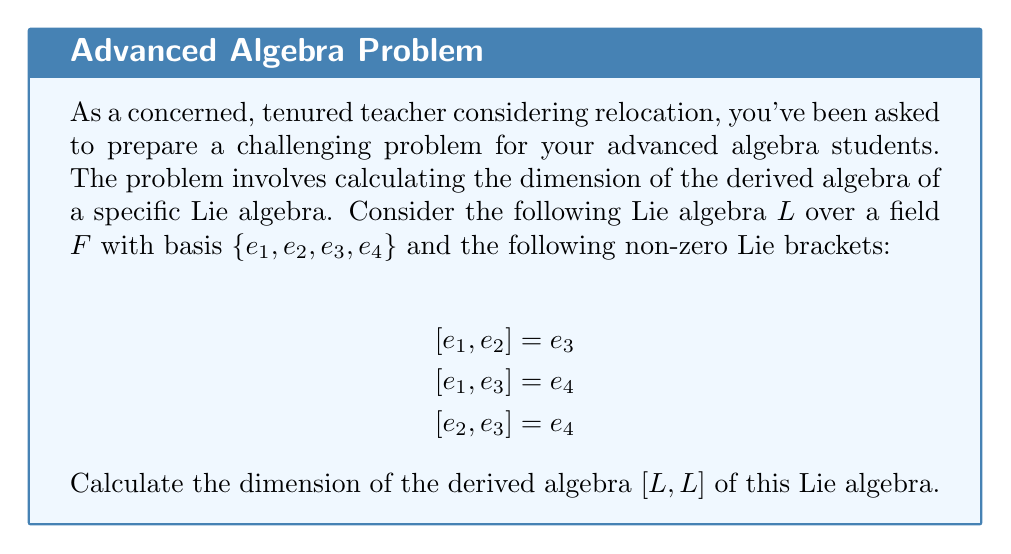What is the answer to this math problem? To solve this problem, we'll follow these steps:

1) First, recall that the derived algebra $[L,L]$ is the subspace of $L$ generated by all Lie brackets $[x,y]$ where $x,y \in L$.

2) From the given Lie brackets, we can see that $e_3$ and $e_4$ are in $[L,L]$. Let's check if there are any other elements:

   $$[e_1, e_4] = [e_2, e_4] = 0$$ (not given, so assumed to be zero)

3) Now, we need to check if $e_3$ and $e_4$ are linearly independent in $[L,L]$:

   Suppose $ae_3 + be_4 = 0$ for some scalars $a,b \in F$.
   
   If $a \neq 0$, then $e_3 = -\frac{b}{a}e_4$. But this contradicts the given Lie bracket $[e_1, e_3] = e_4$.
   
   If $a = 0$, then $be_4 = 0$, which implies $b = 0$ (assuming $e_4 \neq 0$).

4) Therefore, $e_3$ and $e_4$ are linearly independent in $[L,L]$.

5) Since $[L,L]$ is generated by $e_3$ and $e_4$, and these elements are linearly independent, we can conclude that $\{e_3, e_4\}$ forms a basis for $[L,L]$.

6) The dimension of a vector space is equal to the number of elements in its basis.

Therefore, the dimension of $[L,L]$ is 2.
Answer: 2 